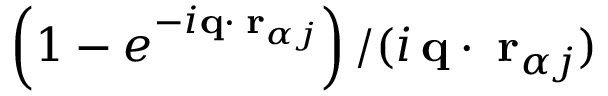Convert formula to latex. <formula><loc_0><loc_0><loc_500><loc_500>\left ( 1 - e ^ { - i { q } \cdot { \delta r } _ { \alpha j } } \right ) / ( i \, { q } \cdot { \delta r } _ { \alpha j } )</formula> 